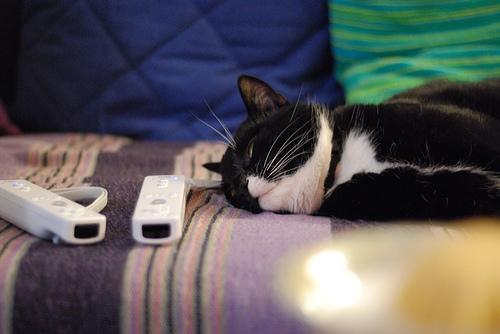How many Wii remotes are there?
Give a very brief answer. 2. How many remotes are visible?
Give a very brief answer. 2. 